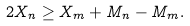Convert formula to latex. <formula><loc_0><loc_0><loc_500><loc_500>2 X _ { n } \geq X _ { m } + M _ { n } - M _ { m } .</formula> 